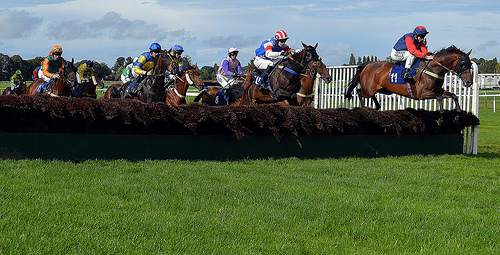<image>
Is there a man behind the fence? No. The man is not behind the fence. From this viewpoint, the man appears to be positioned elsewhere in the scene. 